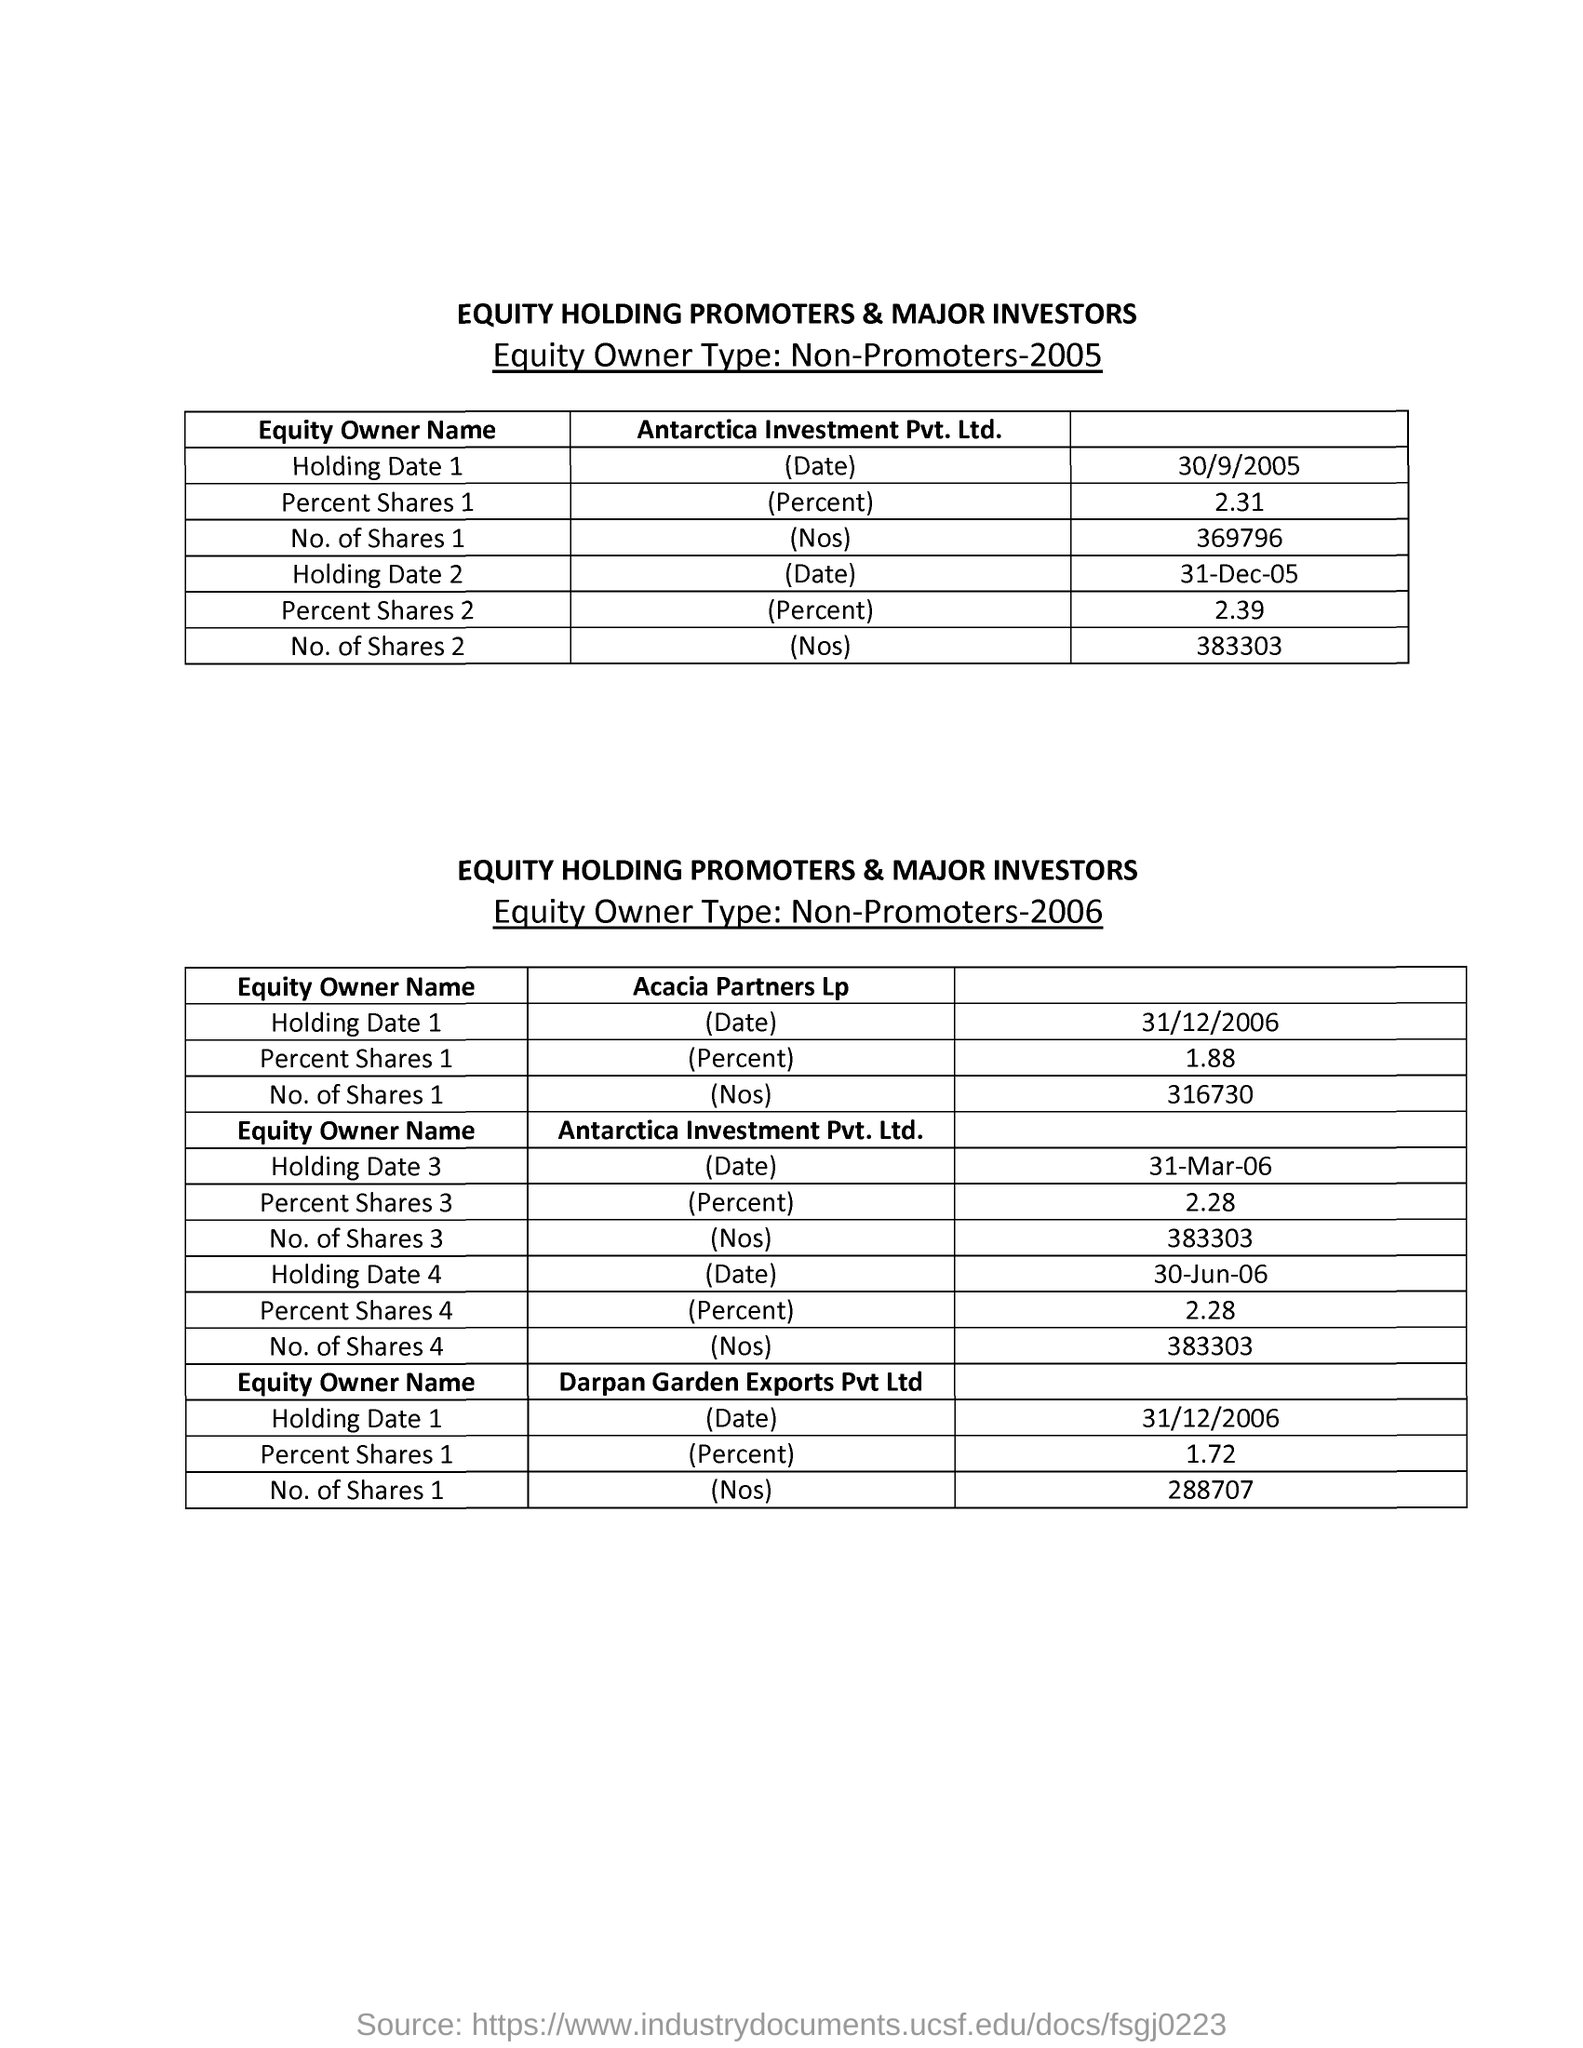Draw attention to some important aspects in this diagram. The number of shares of Antarctica Investment Pvt. Ltd. is 2, and it is 383303. 